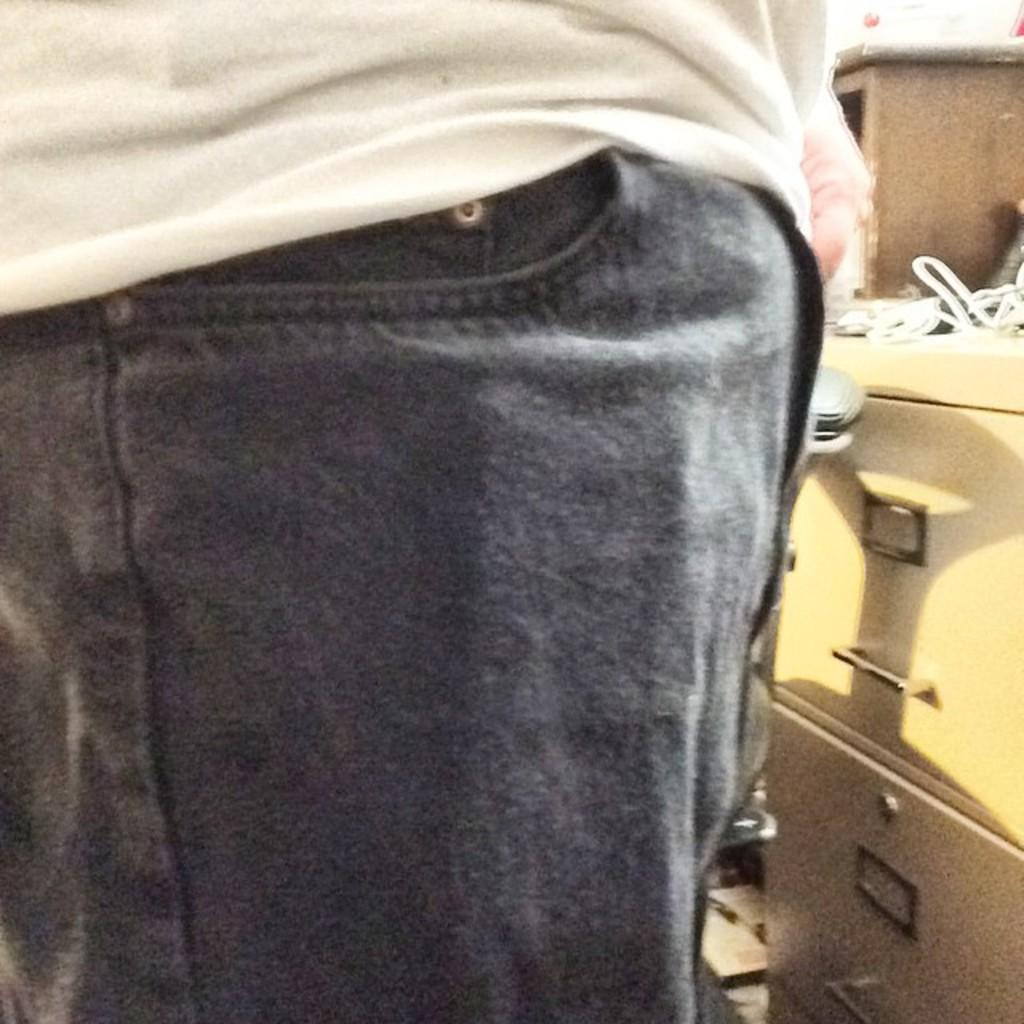What can be seen in the image related to a person? There is a person in the image. What part of the person's clothing is visible? The person's pant pocket is visible. What color is the person's shirt? The person is wearing a white shirt. What type of furniture is present in the image? There is a table with drawers in the image. What type of grain is being harvested by the person in the image? There is no indication of any grain or harvesting activity in the image. 